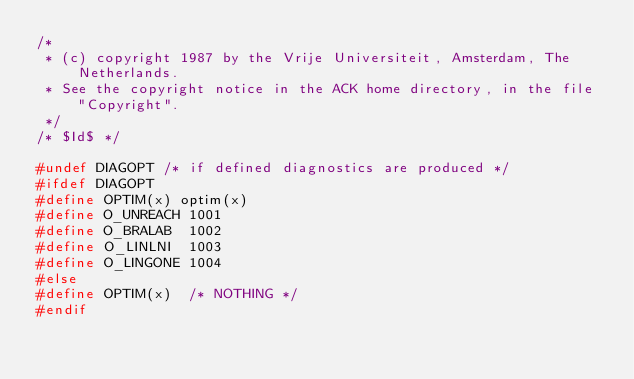<code> <loc_0><loc_0><loc_500><loc_500><_C_>/*
 * (c) copyright 1987 by the Vrije Universiteit, Amsterdam, The Netherlands.
 * See the copyright notice in the ACK home directory, in the file "Copyright".
 */
/* $Id$ */

#undef DIAGOPT /* if defined diagnostics are produced */
#ifdef DIAGOPT
#define OPTIM(x) optim(x)
#define O_UNREACH 1001
#define O_BRALAB  1002
#define O_LINLNI  1003
#define O_LINGONE 1004
#else
#define OPTIM(x)	/* NOTHING */
#endif
</code> 